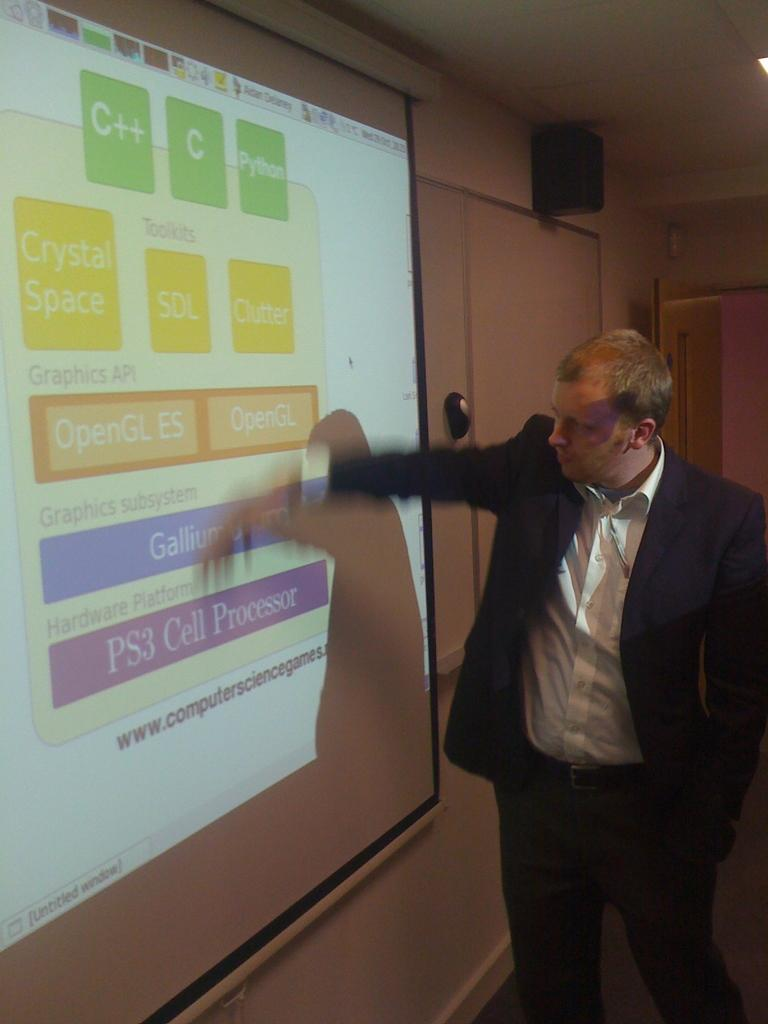<image>
Share a concise interpretation of the image provided. A man gives a presentation on a screen that says C++ on the top. 